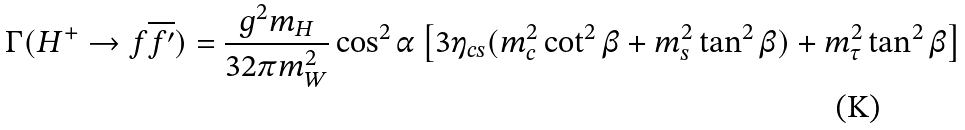<formula> <loc_0><loc_0><loc_500><loc_500>\Gamma ( H ^ { + } \to f \overline { f ^ { \prime } } ) = \frac { g ^ { 2 } m _ { H } } { 3 2 \pi m _ { W } ^ { 2 } } \cos ^ { 2 } \alpha \left [ 3 \eta _ { c s } ( m _ { c } ^ { 2 } \cot ^ { 2 } \beta + m _ { s } ^ { 2 } \tan ^ { 2 } \beta ) + m _ { \tau } ^ { 2 } \tan ^ { 2 } \beta \right ]</formula> 